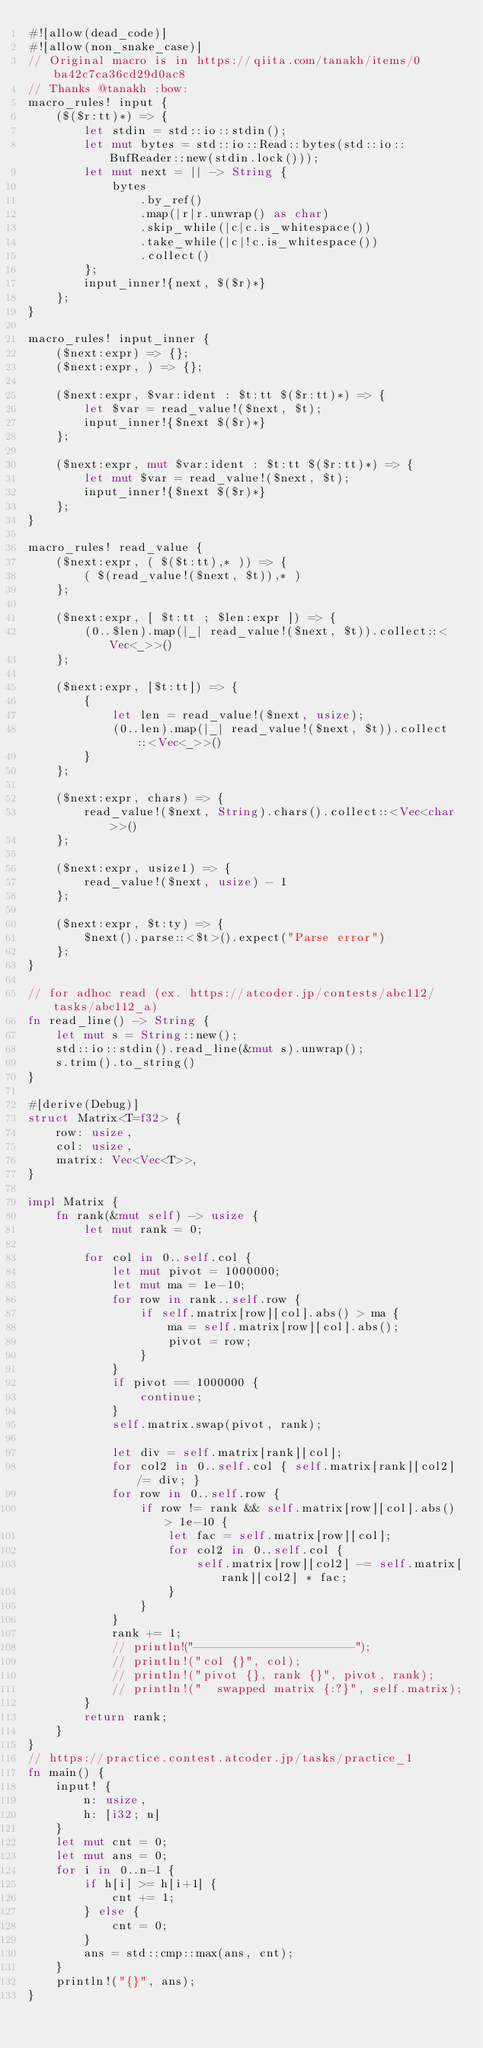<code> <loc_0><loc_0><loc_500><loc_500><_Rust_>#![allow(dead_code)]
#![allow(non_snake_case)]
// Original macro is in https://qiita.com/tanakh/items/0ba42c7ca36cd29d0ac8
// Thanks @tanakh :bow:
macro_rules! input {
    ($($r:tt)*) => {
        let stdin = std::io::stdin();
        let mut bytes = std::io::Read::bytes(std::io::BufReader::new(stdin.lock()));
        let mut next = || -> String {
            bytes
                .by_ref()
                .map(|r|r.unwrap() as char)
                .skip_while(|c|c.is_whitespace())
                .take_while(|c|!c.is_whitespace())
                .collect()
        };
        input_inner!{next, $($r)*}
    };
}
 
macro_rules! input_inner {
    ($next:expr) => {};
    ($next:expr, ) => {};
 
    ($next:expr, $var:ident : $t:tt $($r:tt)*) => {
        let $var = read_value!($next, $t);
        input_inner!{$next $($r)*}
    };
    
    ($next:expr, mut $var:ident : $t:tt $($r:tt)*) => {
        let mut $var = read_value!($next, $t);
        input_inner!{$next $($r)*}
    };
}
 
macro_rules! read_value {
    ($next:expr, ( $($t:tt),* )) => {
        ( $(read_value!($next, $t)),* )
    };
 
    ($next:expr, [ $t:tt ; $len:expr ]) => {
        (0..$len).map(|_| read_value!($next, $t)).collect::<Vec<_>>()
    };

    ($next:expr, [$t:tt]) => {
        {
            let len = read_value!($next, usize);
            (0..len).map(|_| read_value!($next, $t)).collect::<Vec<_>>()
        }
    };
 
    ($next:expr, chars) => {
        read_value!($next, String).chars().collect::<Vec<char>>()
    };
 
    ($next:expr, usize1) => {
        read_value!($next, usize) - 1
    };
 
    ($next:expr, $t:ty) => {
        $next().parse::<$t>().expect("Parse error")
    };
}

// for adhoc read (ex. https://atcoder.jp/contests/abc112/tasks/abc112_a)
fn read_line() -> String {
    let mut s = String::new();
    std::io::stdin().read_line(&mut s).unwrap();
    s.trim().to_string()
}

#[derive(Debug)]
struct Matrix<T=f32> {
    row: usize,
    col: usize,
    matrix: Vec<Vec<T>>,
}

impl Matrix {
    fn rank(&mut self) -> usize {
        let mut rank = 0;

        for col in 0..self.col {
            let mut pivot = 1000000;
            let mut ma = 1e-10;
            for row in rank..self.row {
                if self.matrix[row][col].abs() > ma {
                    ma = self.matrix[row][col].abs();
                    pivot = row;
                }
            }
            if pivot == 1000000 {
                continue;
            }
            self.matrix.swap(pivot, rank);

            let div = self.matrix[rank][col];
            for col2 in 0..self.col { self.matrix[rank][col2] /= div; }
            for row in 0..self.row {
                if row != rank && self.matrix[row][col].abs() > 1e-10 {
                    let fac = self.matrix[row][col];
                    for col2 in 0..self.col {
                        self.matrix[row][col2] -= self.matrix[rank][col2] * fac;
                    }
                }
            }
            rank += 1;
            // println!("---------------------");
            // println!("col {}", col);
            // println!("pivot {}, rank {}", pivot, rank);
            // println!("  swapped matrix {:?}", self.matrix);
        }
        return rank;
    }
}
// https://practice.contest.atcoder.jp/tasks/practice_1
fn main() {
    input! {
        n: usize,
        h: [i32; n]
    }
    let mut cnt = 0;
    let mut ans = 0;
    for i in 0..n-1 {
        if h[i] >= h[i+1] {
            cnt += 1;
        } else {
            cnt = 0;
        }
        ans = std::cmp::max(ans, cnt);
    }
    println!("{}", ans);
}
</code> 